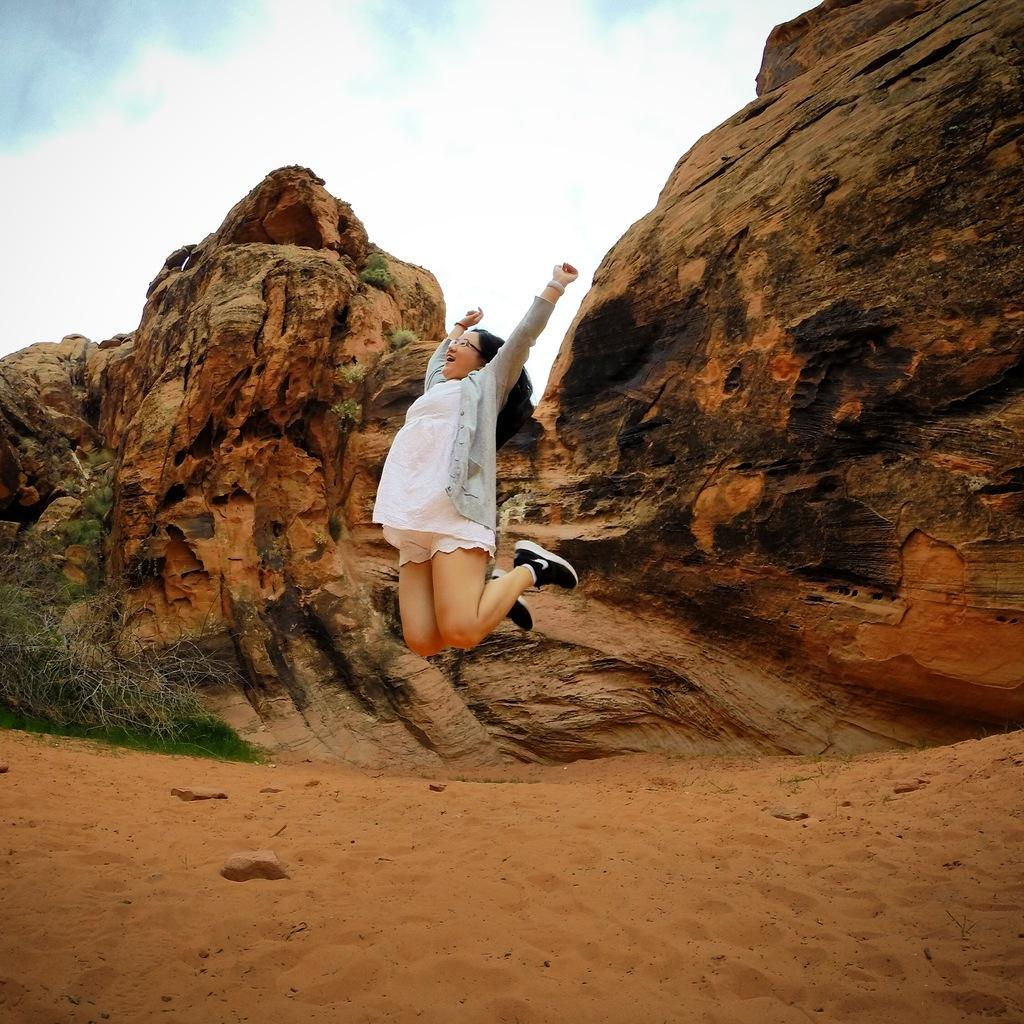What is the person in the image doing? The person is in the air in the image. What type of terrain can be seen in the background of the image? There is sand, trees, and rock hills visible in the background of the image. What part of the natural environment is visible in the image? The sky is visible in the background of the image. What type of food is the person eating while flying in the image? There is no food present in the image; the person is in the air without any visible food. 